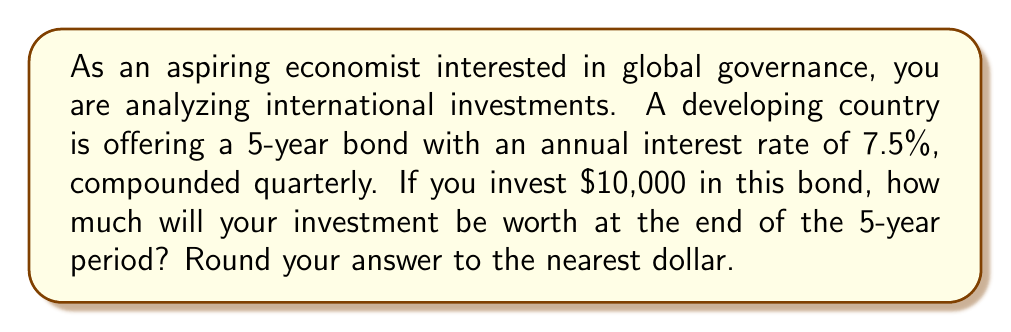Give your solution to this math problem. To solve this problem, we'll use the compound interest formula:

$$A = P(1 + \frac{r}{n})^{nt}$$

Where:
$A$ = Final amount
$P$ = Principal (initial investment)
$r$ = Annual interest rate (in decimal form)
$n$ = Number of times interest is compounded per year
$t$ = Number of years

Given:
$P = 10,000$
$r = 0.075$ (7.5% expressed as a decimal)
$n = 4$ (compounded quarterly, so 4 times per year)
$t = 5$ years

Let's substitute these values into the formula:

$$A = 10,000(1 + \frac{0.075}{4})^{4 \cdot 5}$$

$$A = 10,000(1 + 0.01875)^{20}$$

$$A = 10,000(1.01875)^{20}$$

Now, let's calculate this step by step:

1. Calculate $(1.01875)^{20}$:
   $(1.01875)^{20} \approx 1.45132$

2. Multiply by the principal:
   $10,000 \cdot 1.45132 = 14,513.20$

3. Round to the nearest dollar:
   $14,513$
Answer: $14,513 